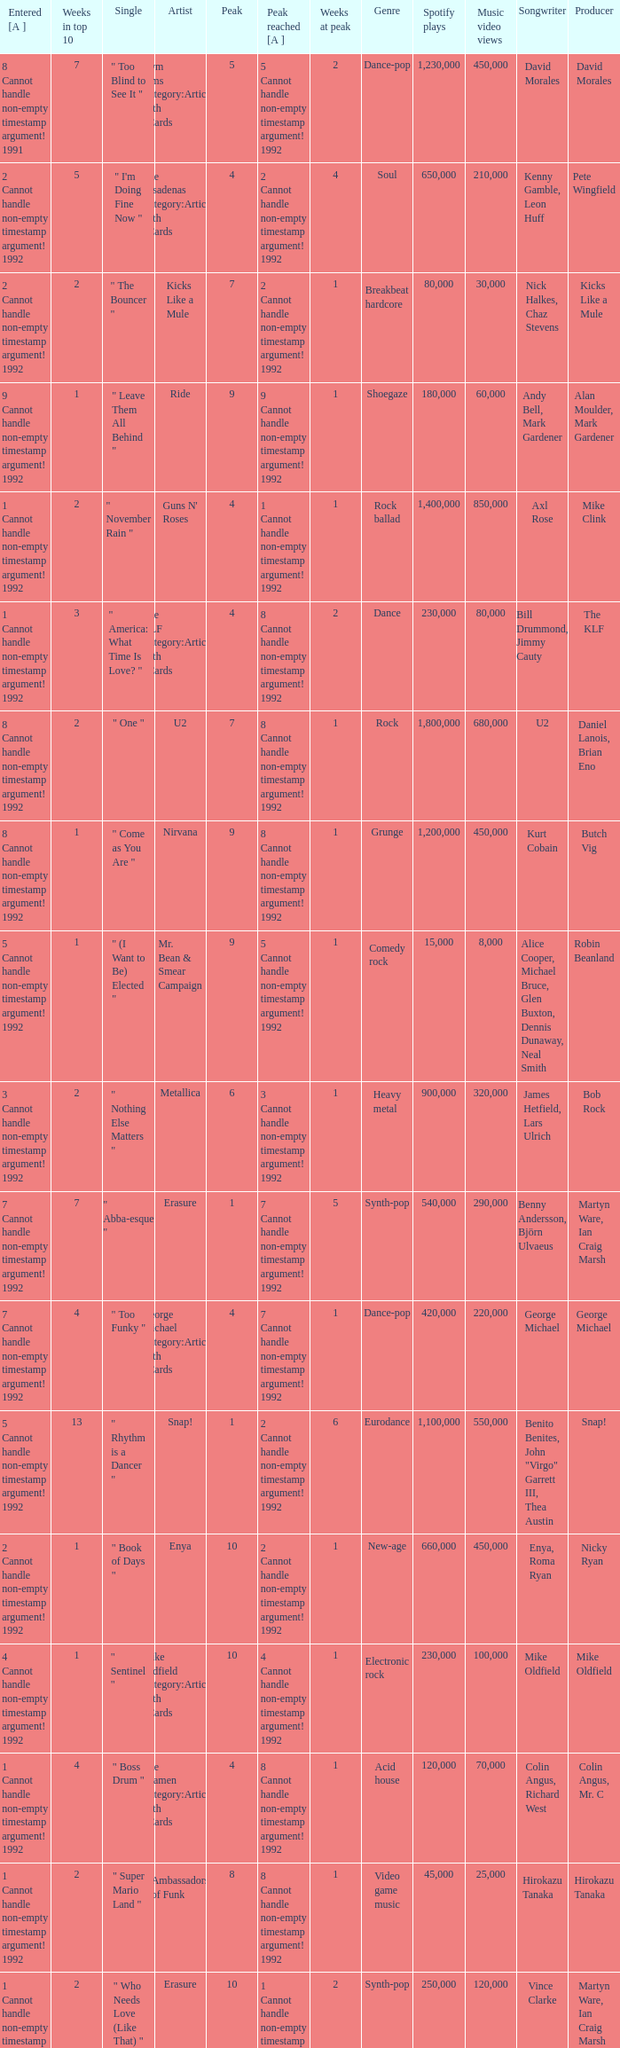If the peak reached is 6 cannot handle non-empty timestamp argument! 1992, what is the entered? 6 Cannot handle non-empty timestamp argument! 1992. 